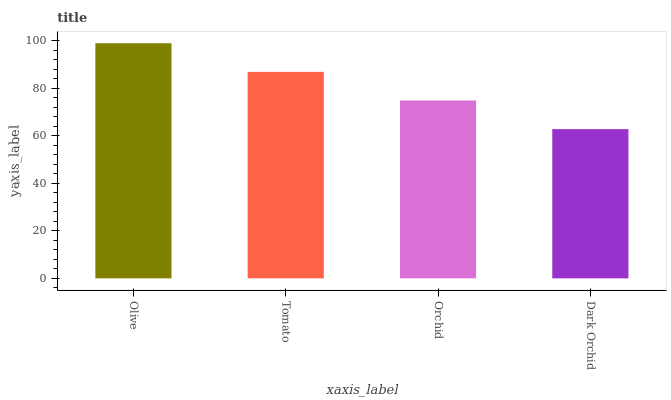Is Dark Orchid the minimum?
Answer yes or no. Yes. Is Olive the maximum?
Answer yes or no. Yes. Is Tomato the minimum?
Answer yes or no. No. Is Tomato the maximum?
Answer yes or no. No. Is Olive greater than Tomato?
Answer yes or no. Yes. Is Tomato less than Olive?
Answer yes or no. Yes. Is Tomato greater than Olive?
Answer yes or no. No. Is Olive less than Tomato?
Answer yes or no. No. Is Tomato the high median?
Answer yes or no. Yes. Is Orchid the low median?
Answer yes or no. Yes. Is Dark Orchid the high median?
Answer yes or no. No. Is Tomato the low median?
Answer yes or no. No. 